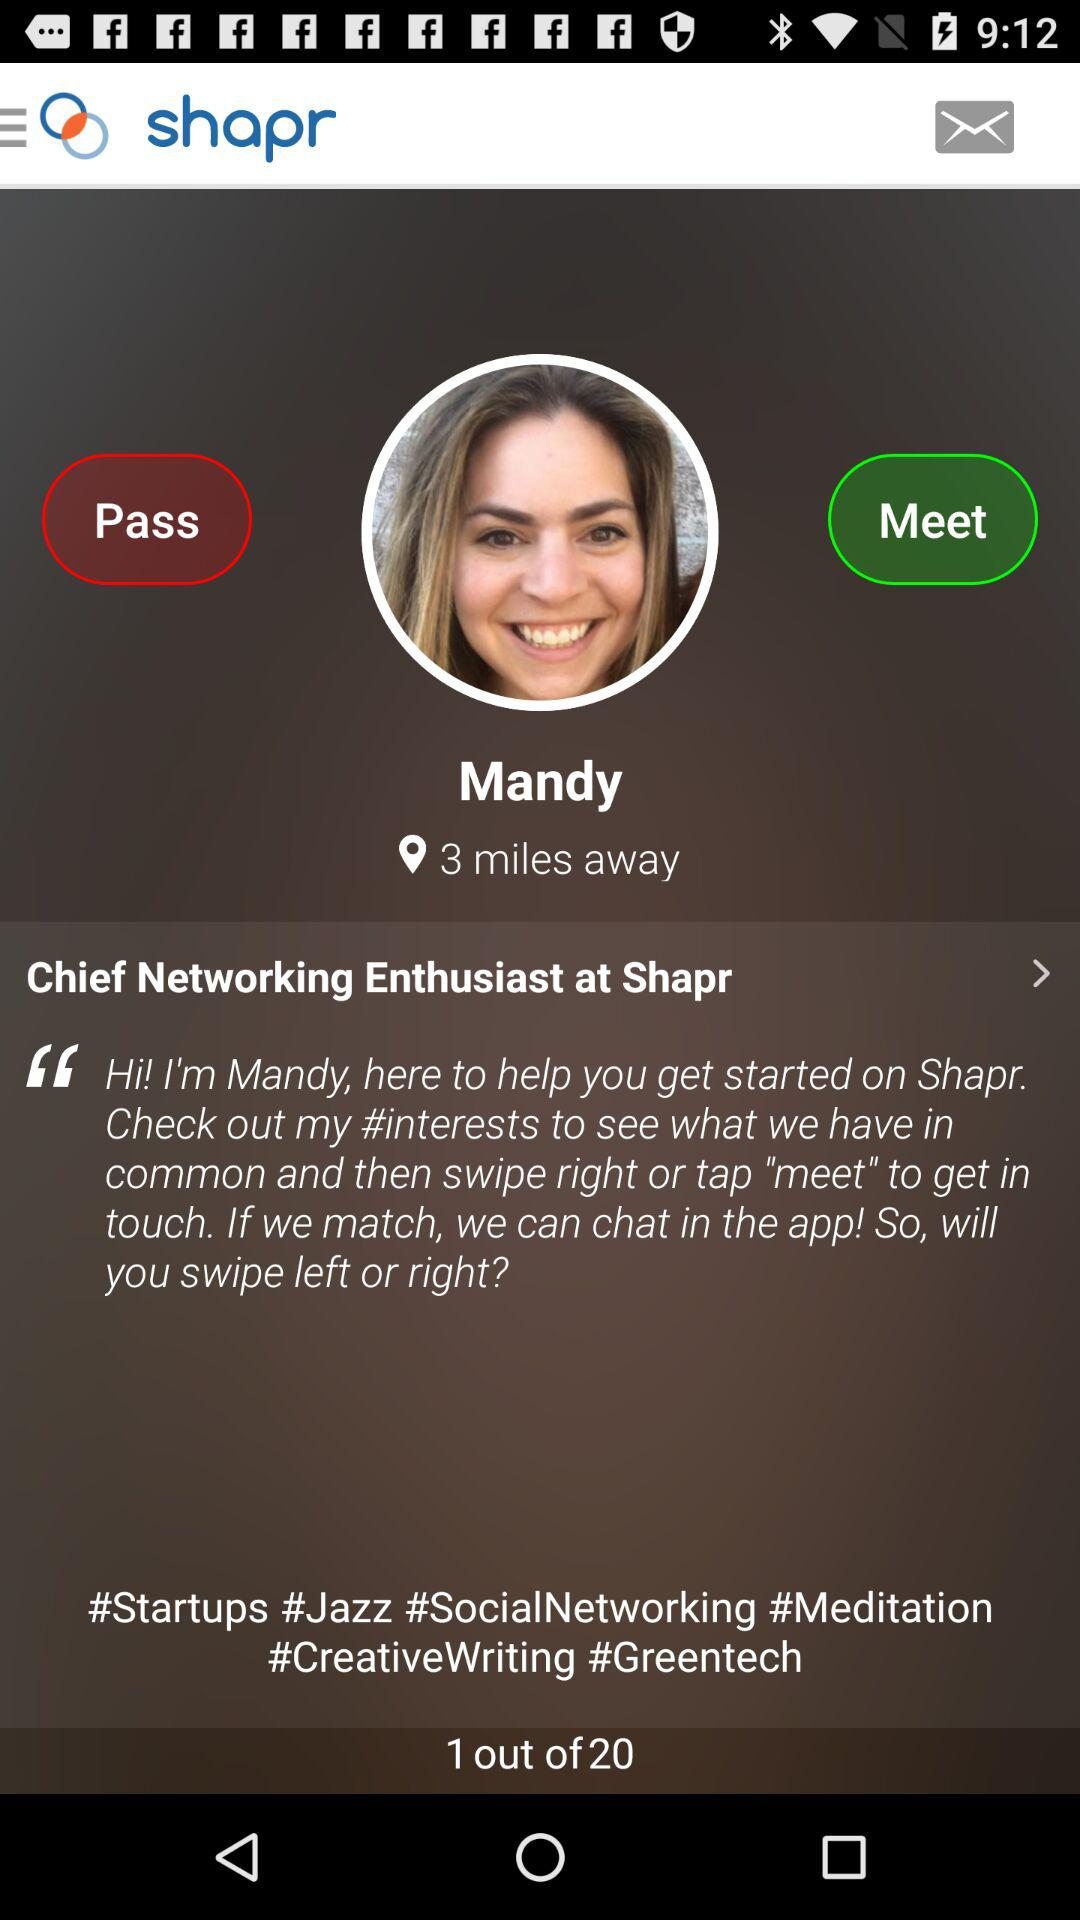What are the areas of interest mentioned by the user? The areas of interest mentioned by the user are "Startups", "Jazz", "Social Networking", "Meditation", "CreativeWriting" and "Greentech". 